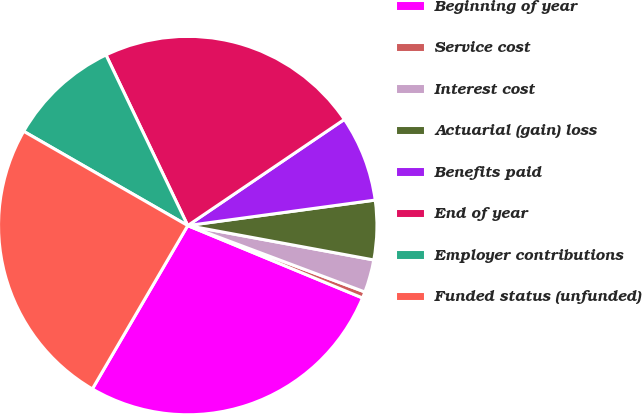<chart> <loc_0><loc_0><loc_500><loc_500><pie_chart><fcel>Beginning of year<fcel>Service cost<fcel>Interest cost<fcel>Actuarial (gain) loss<fcel>Benefits paid<fcel>End of year<fcel>Employer contributions<fcel>Funded status (unfunded)<nl><fcel>27.16%<fcel>0.54%<fcel>2.8%<fcel>5.06%<fcel>7.33%<fcel>22.63%<fcel>9.59%<fcel>24.89%<nl></chart> 